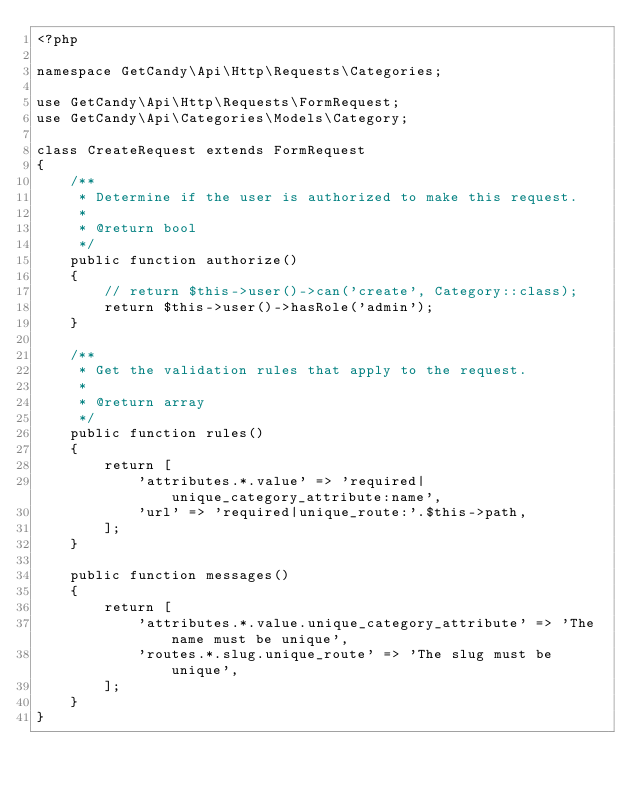<code> <loc_0><loc_0><loc_500><loc_500><_PHP_><?php

namespace GetCandy\Api\Http\Requests\Categories;

use GetCandy\Api\Http\Requests\FormRequest;
use GetCandy\Api\Categories\Models\Category;

class CreateRequest extends FormRequest
{
    /**
     * Determine if the user is authorized to make this request.
     *
     * @return bool
     */
    public function authorize()
    {
        // return $this->user()->can('create', Category::class);
        return $this->user()->hasRole('admin');
    }

    /**
     * Get the validation rules that apply to the request.
     *
     * @return array
     */
    public function rules()
    {
        return [
            'attributes.*.value' => 'required|unique_category_attribute:name',
            'url' => 'required|unique_route:'.$this->path,
        ];
    }

    public function messages()
    {
        return [
            'attributes.*.value.unique_category_attribute' => 'The name must be unique',
            'routes.*.slug.unique_route' => 'The slug must be unique',
        ];
    }
}
</code> 